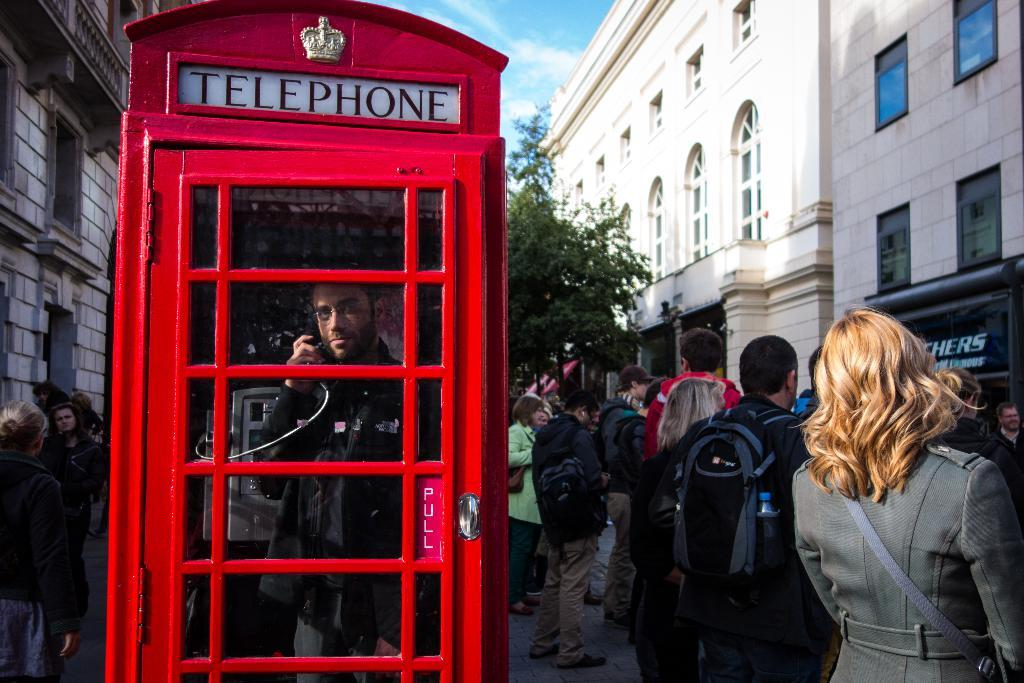<image>
Provide a brief description of the given image. A red telephone booth on a populated sidewalk outside of a Sketchers store. 